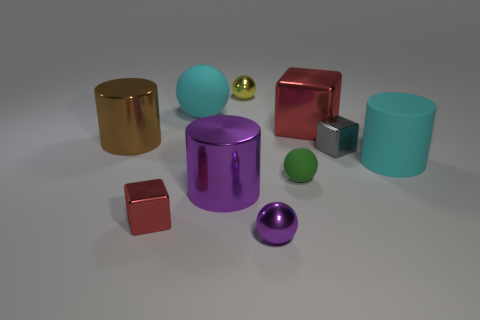How big is the metallic object that is on the left side of the large cube and behind the large brown shiny cylinder?
Offer a terse response. Small. What is the shape of the red metal thing to the right of the tiny metal ball that is behind the big brown metal cylinder?
Offer a very short reply. Cube. Are there any other things that are the same color as the matte cylinder?
Offer a very short reply. Yes. There is a big cyan matte object that is in front of the large brown cylinder; what shape is it?
Your response must be concise. Cylinder. There is a large object that is in front of the brown cylinder and left of the yellow shiny thing; what is its shape?
Offer a very short reply. Cylinder. How many red objects are either large spheres or large metal things?
Ensure brevity in your answer.  1. There is a small thing that is on the right side of the small rubber sphere; is it the same color as the big matte cylinder?
Offer a terse response. No. There is a red thing that is behind the large cyan object in front of the cyan rubber sphere; what size is it?
Ensure brevity in your answer.  Large. What is the material of the red thing that is the same size as the gray object?
Give a very brief answer. Metal. How many other objects are the same size as the yellow object?
Offer a very short reply. 4. 